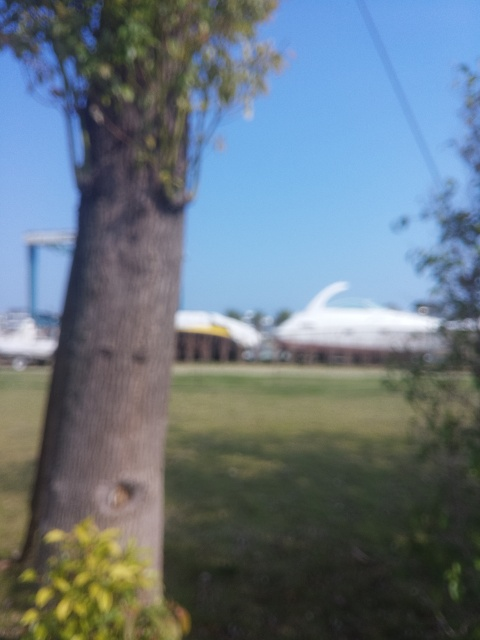Is the focusing accurate? B. No, the image is blurry and the focus is not sharp on any particular object. For a photograph to be considered properly focused, the subject or a significant portion of the scene should be sharp and clear, which is not the case here. 